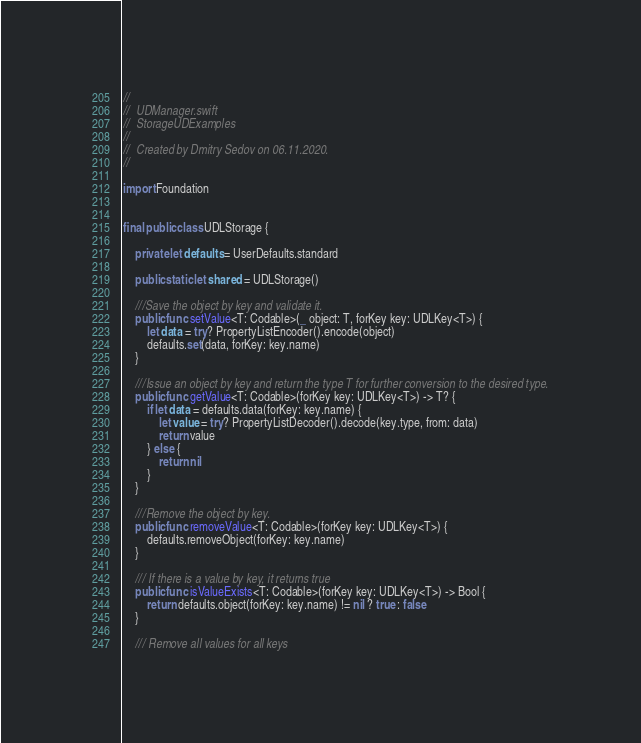<code> <loc_0><loc_0><loc_500><loc_500><_Swift_>//
//  UDManager.swift
//  StorageUDExamples
//
//  Created by Dmitry Sedov on 06.11.2020.
//

import Foundation


final public class UDLStorage {
    
    private let defaults = UserDefaults.standard
    
    public static let shared = UDLStorage()
    
    ///Save the object by key and validate it.
    public func setValue<T: Codable>(_ object: T, forKey key: UDLKey<T>) {
        let data = try? PropertyListEncoder().encode(object)
        defaults.set(data, forKey: key.name)
    }
    
    ///Issue an object by key and return the type T for further conversion to the desired type.
    public func getValue<T: Codable>(forKey key: UDLKey<T>) -> T? {
        if let data = defaults.data(forKey: key.name) {
            let value = try? PropertyListDecoder().decode(key.type, from: data)
            return value
        } else {
            return nil
        }
    }
    
    ///Remove the object by key.
    public func removeValue<T: Codable>(forKey key: UDLKey<T>) {
        defaults.removeObject(forKey: key.name)
    }
    
    /// If there is a value by key, it returns true
    public func isValueExists<T: Codable>(forKey key: UDLKey<T>) -> Bool {
        return defaults.object(forKey: key.name) != nil ? true : false
    }
    
    /// Remove all values for all keys</code> 